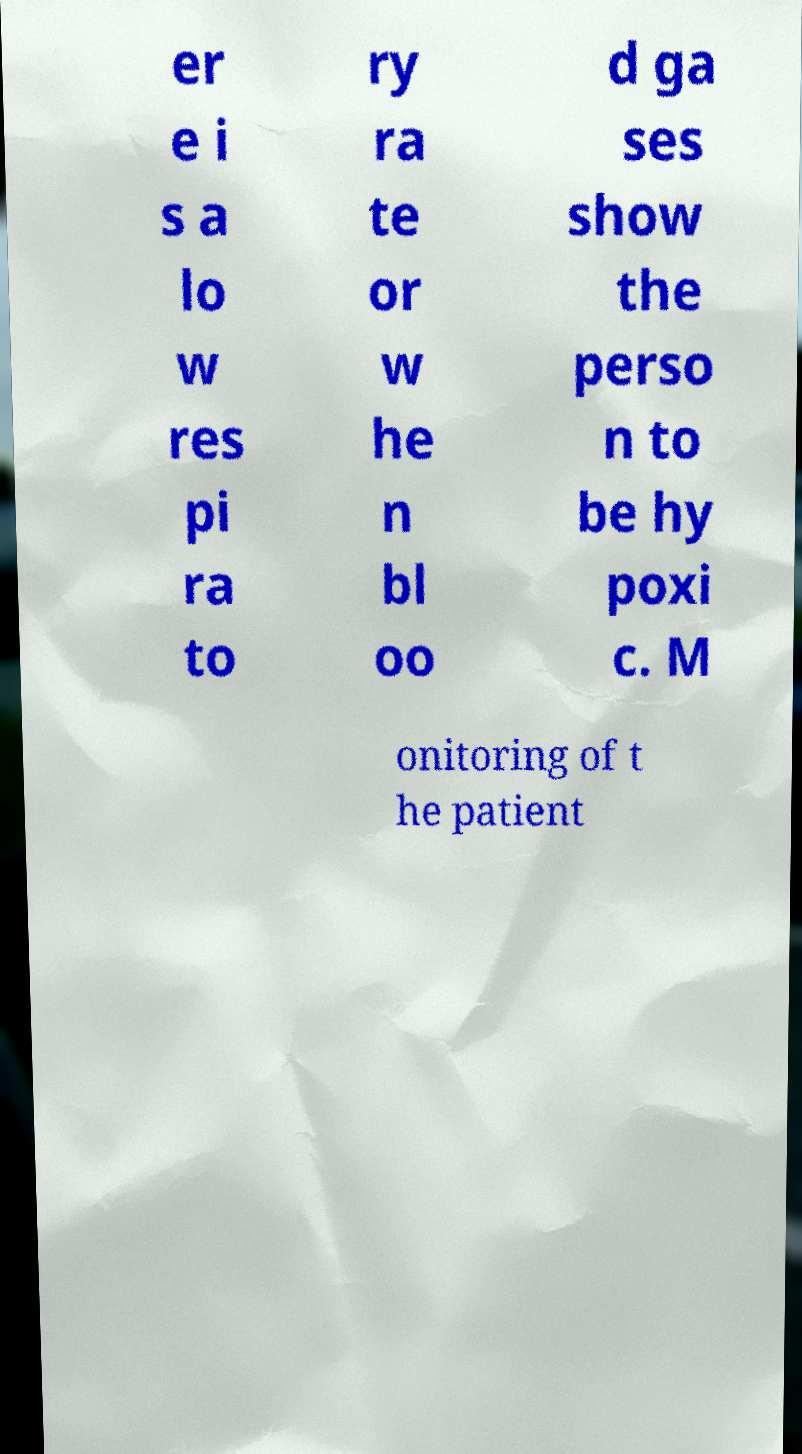Please identify and transcribe the text found in this image. er e i s a lo w res pi ra to ry ra te or w he n bl oo d ga ses show the perso n to be hy poxi c. M onitoring of t he patient 